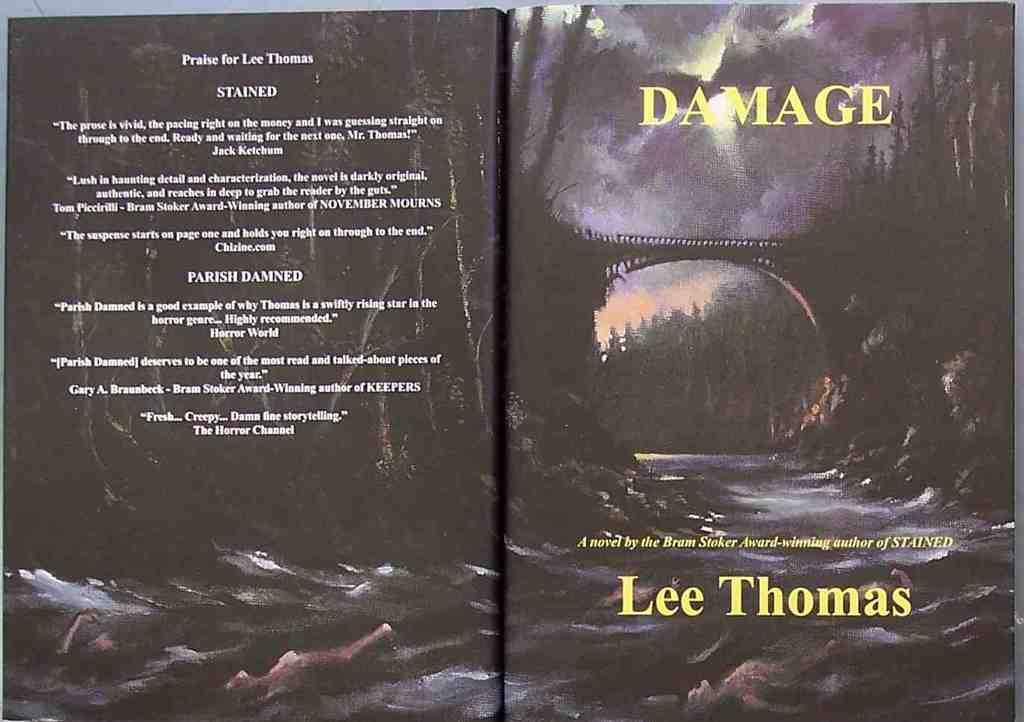<image>
Describe the image concisely. a book titled damage by lee thomas, an award winning author 